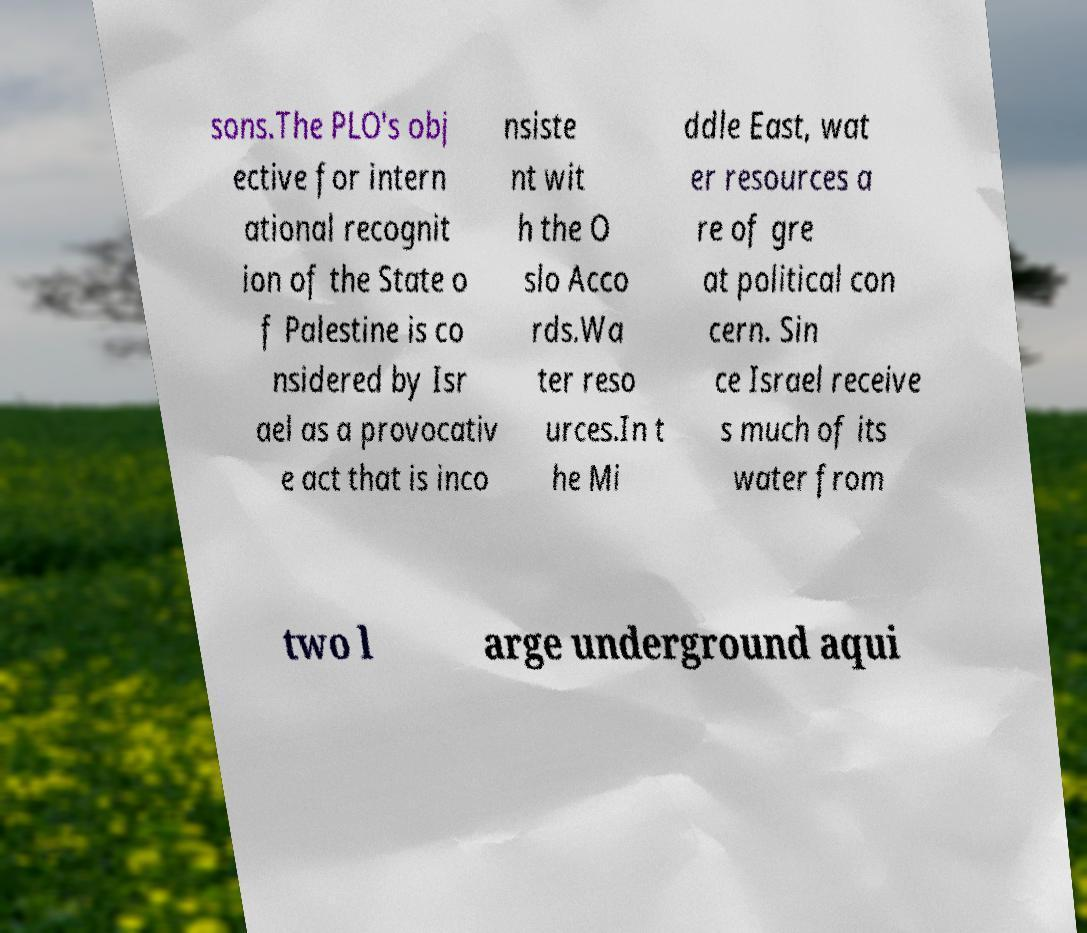What messages or text are displayed in this image? I need them in a readable, typed format. sons.The PLO's obj ective for intern ational recognit ion of the State o f Palestine is co nsidered by Isr ael as a provocativ e act that is inco nsiste nt wit h the O slo Acco rds.Wa ter reso urces.In t he Mi ddle East, wat er resources a re of gre at political con cern. Sin ce Israel receive s much of its water from two l arge underground aqui 